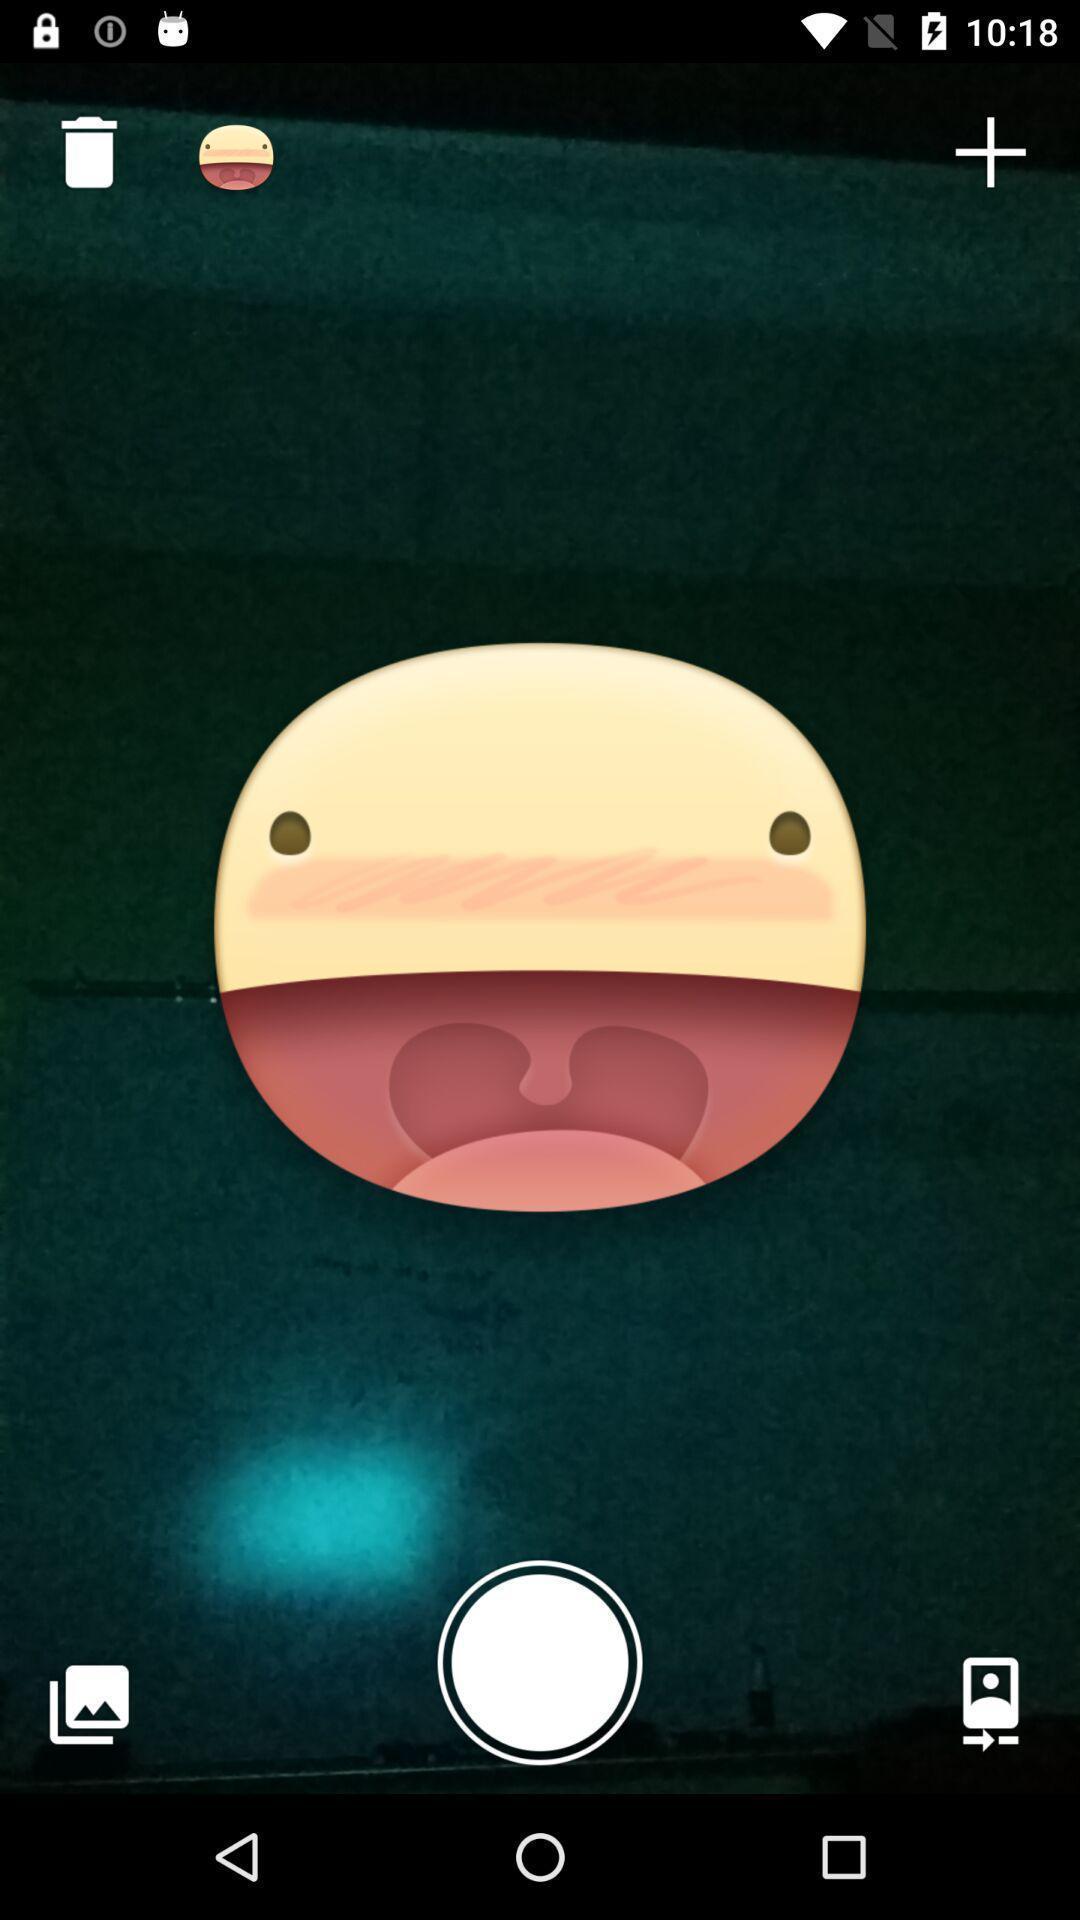What can you discern from this picture? Screen displaying the darkness image with emoji. 